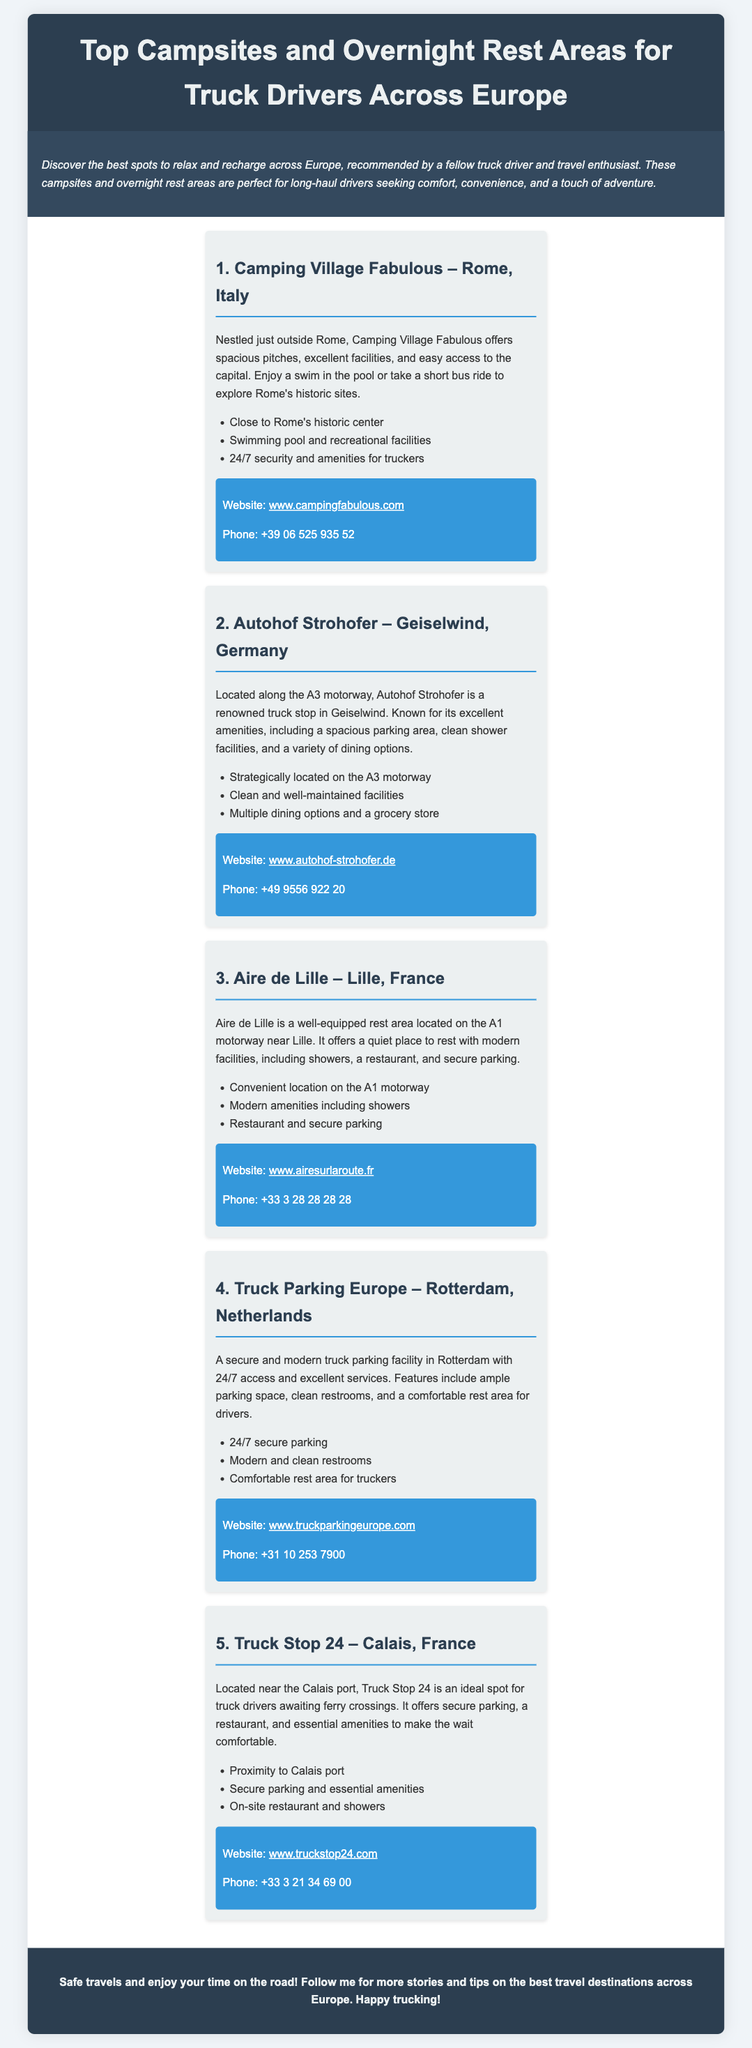What is the name of the campsite near Rome? The name of the campsite near Rome is Camping Village Fabulous.
Answer: Camping Village Fabulous What is the contact phone number for Autohof Strohofer? The contact phone number for Autohof Strohofer is listed in the document.
Answer: +49 9556 922 20 Which two countries have truck stops mentioned in the document? The document lists truck stops in France and Germany, among other countries.
Answer: France and Germany What amenities does Truck Stop 24 provide? Truck Stop 24 offers secure parking, a restaurant, and essential amenities as stated in the document.
Answer: Secure parking, restaurant, essential amenities How many sections are there in the document? The document features five sections detailing different campsites and rest areas.
Answer: Five 